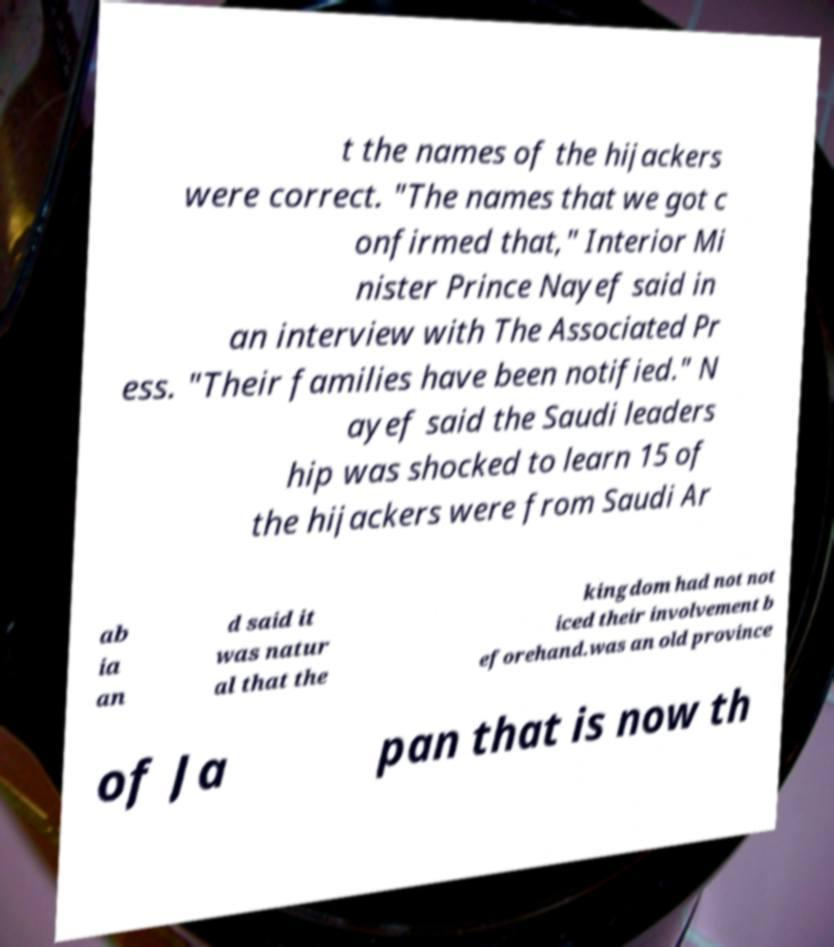Can you read and provide the text displayed in the image?This photo seems to have some interesting text. Can you extract and type it out for me? t the names of the hijackers were correct. "The names that we got c onfirmed that," Interior Mi nister Prince Nayef said in an interview with The Associated Pr ess. "Their families have been notified." N ayef said the Saudi leaders hip was shocked to learn 15 of the hijackers were from Saudi Ar ab ia an d said it was natur al that the kingdom had not not iced their involvement b eforehand.was an old province of Ja pan that is now th 